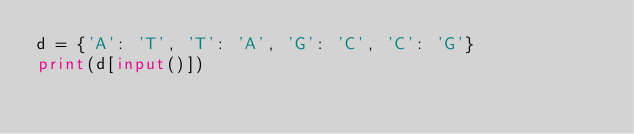<code> <loc_0><loc_0><loc_500><loc_500><_Python_>d = {'A': 'T', 'T': 'A', 'G': 'C', 'C': 'G'}
print(d[input()])</code> 